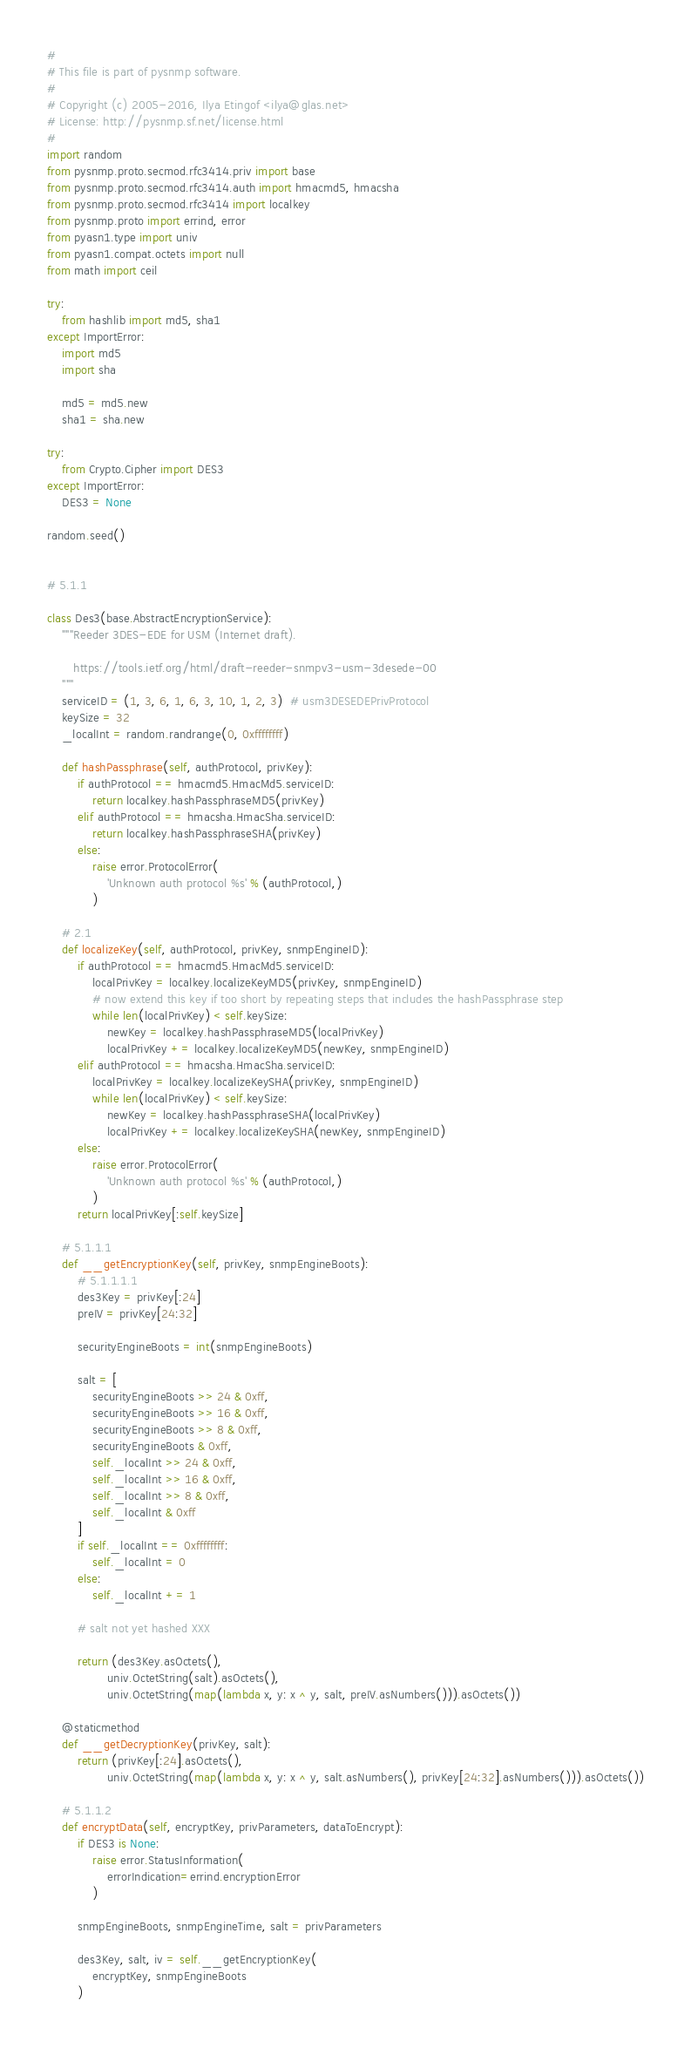Convert code to text. <code><loc_0><loc_0><loc_500><loc_500><_Python_>#
# This file is part of pysnmp software.
#
# Copyright (c) 2005-2016, Ilya Etingof <ilya@glas.net>
# License: http://pysnmp.sf.net/license.html
#
import random
from pysnmp.proto.secmod.rfc3414.priv import base
from pysnmp.proto.secmod.rfc3414.auth import hmacmd5, hmacsha
from pysnmp.proto.secmod.rfc3414 import localkey
from pysnmp.proto import errind, error
from pyasn1.type import univ
from pyasn1.compat.octets import null
from math import ceil

try:
    from hashlib import md5, sha1
except ImportError:
    import md5
    import sha

    md5 = md5.new
    sha1 = sha.new

try:
    from Crypto.Cipher import DES3
except ImportError:
    DES3 = None

random.seed()


# 5.1.1

class Des3(base.AbstractEncryptionService):
    """Reeder 3DES-EDE for USM (Internet draft).

       https://tools.ietf.org/html/draft-reeder-snmpv3-usm-3desede-00
    """
    serviceID = (1, 3, 6, 1, 6, 3, 10, 1, 2, 3)  # usm3DESEDEPrivProtocol
    keySize = 32
    _localInt = random.randrange(0, 0xffffffff)

    def hashPassphrase(self, authProtocol, privKey):
        if authProtocol == hmacmd5.HmacMd5.serviceID:
            return localkey.hashPassphraseMD5(privKey)
        elif authProtocol == hmacsha.HmacSha.serviceID:
            return localkey.hashPassphraseSHA(privKey)
        else:
            raise error.ProtocolError(
                'Unknown auth protocol %s' % (authProtocol,)
            )

    # 2.1
    def localizeKey(self, authProtocol, privKey, snmpEngineID):
        if authProtocol == hmacmd5.HmacMd5.serviceID:
            localPrivKey = localkey.localizeKeyMD5(privKey, snmpEngineID)
            # now extend this key if too short by repeating steps that includes the hashPassphrase step
            while len(localPrivKey) < self.keySize:
                newKey = localkey.hashPassphraseMD5(localPrivKey)
                localPrivKey += localkey.localizeKeyMD5(newKey, snmpEngineID)
        elif authProtocol == hmacsha.HmacSha.serviceID:
            localPrivKey = localkey.localizeKeySHA(privKey, snmpEngineID)
            while len(localPrivKey) < self.keySize:
                newKey = localkey.hashPassphraseSHA(localPrivKey)
                localPrivKey += localkey.localizeKeySHA(newKey, snmpEngineID)
        else:
            raise error.ProtocolError(
                'Unknown auth protocol %s' % (authProtocol,)
            )
        return localPrivKey[:self.keySize]

    # 5.1.1.1
    def __getEncryptionKey(self, privKey, snmpEngineBoots):
        # 5.1.1.1.1
        des3Key = privKey[:24]
        preIV = privKey[24:32]

        securityEngineBoots = int(snmpEngineBoots)

        salt = [
            securityEngineBoots >> 24 & 0xff,
            securityEngineBoots >> 16 & 0xff,
            securityEngineBoots >> 8 & 0xff,
            securityEngineBoots & 0xff,
            self._localInt >> 24 & 0xff,
            self._localInt >> 16 & 0xff,
            self._localInt >> 8 & 0xff,
            self._localInt & 0xff
        ]
        if self._localInt == 0xffffffff:
            self._localInt = 0
        else:
            self._localInt += 1

        # salt not yet hashed XXX

        return (des3Key.asOctets(),
                univ.OctetString(salt).asOctets(),
                univ.OctetString(map(lambda x, y: x ^ y, salt, preIV.asNumbers())).asOctets())

    @staticmethod
    def __getDecryptionKey(privKey, salt):
        return (privKey[:24].asOctets(),
                univ.OctetString(map(lambda x, y: x ^ y, salt.asNumbers(), privKey[24:32].asNumbers())).asOctets())

    # 5.1.1.2
    def encryptData(self, encryptKey, privParameters, dataToEncrypt):
        if DES3 is None:
            raise error.StatusInformation(
                errorIndication=errind.encryptionError
            )

        snmpEngineBoots, snmpEngineTime, salt = privParameters

        des3Key, salt, iv = self.__getEncryptionKey(
            encryptKey, snmpEngineBoots
        )
</code> 